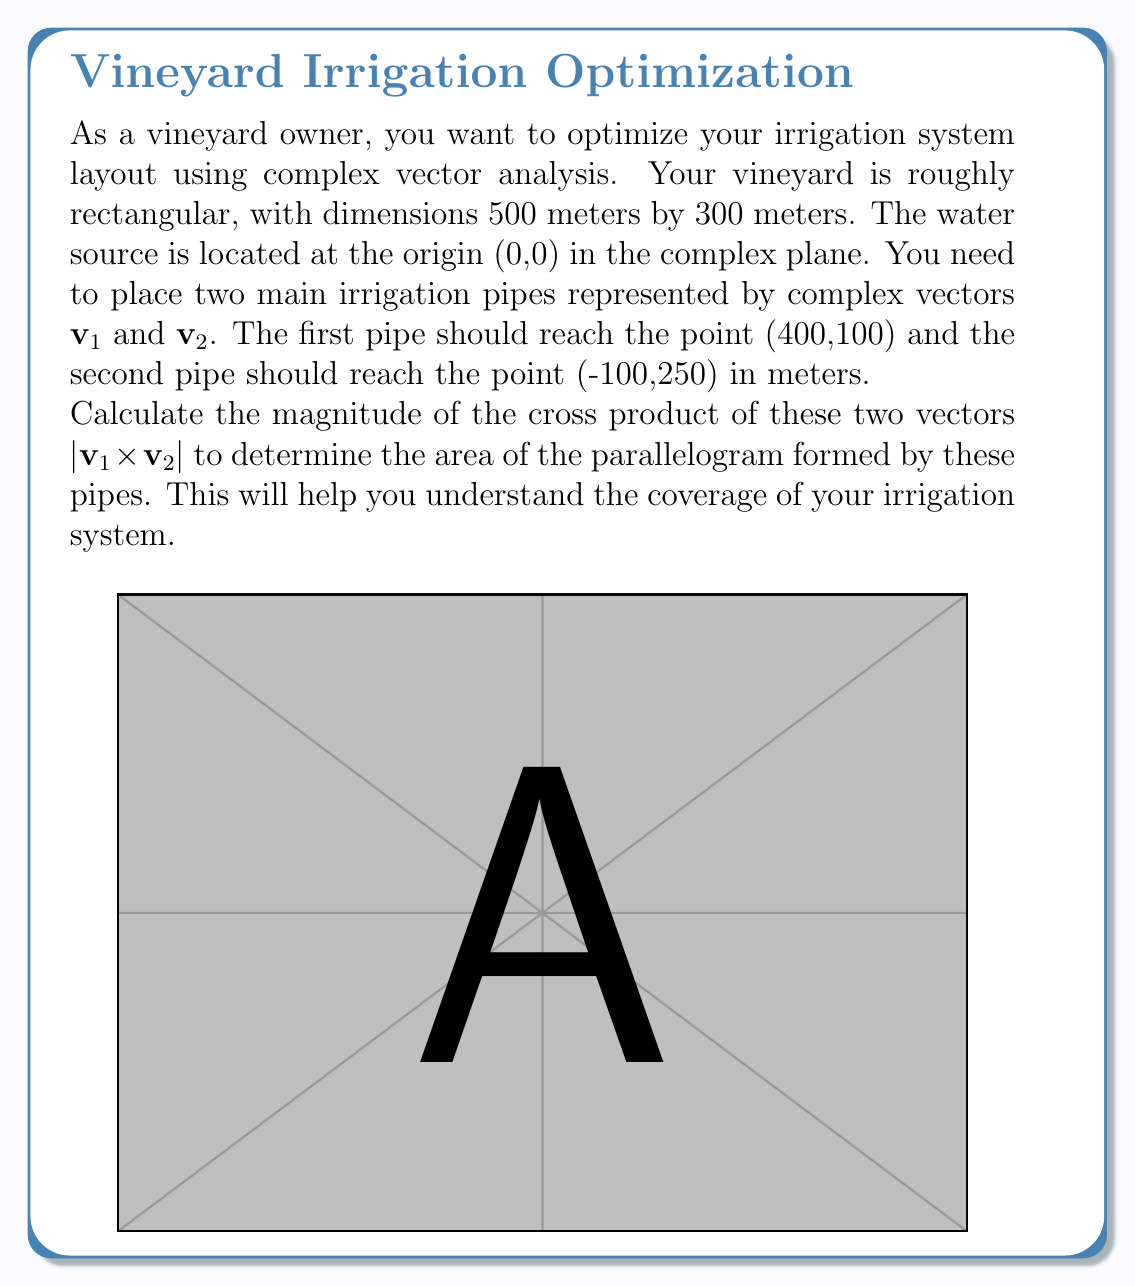Solve this math problem. Let's approach this step-by-step:

1) First, we need to represent the vectors in complex form:
   $\mathbf{v}_1 = 400 + 100i$
   $\mathbf{v}_2 = -100 + 250i$

2) To find the cross product of two complex vectors $\mathbf{a} = a_1 + a_2i$ and $\mathbf{b} = b_1 + b_2i$, we use the formula:
   $$|\mathbf{a} \times \mathbf{b}| = |a_1b_2 - a_2b_1|$$

3) In our case:
   $a_1 = 400$, $a_2 = 100$
   $b_1 = -100$, $b_2 = 250$

4) Let's substitute these values into the formula:
   $$|\mathbf{v}_1 \times \mathbf{v}_2| = |400(250) - 100(-100)|$$

5) Simplify:
   $$|\mathbf{v}_1 \times \mathbf{v}_2| = |100,000 + 10,000| = |110,000|$$

6) The absolute value of a positive number is the number itself, so:
   $$|\mathbf{v}_1 \times \mathbf{v}_2| = 110,000$$

7) This result is in square meters, as we multiplied distances in meters.

The magnitude of the cross product, 110,000 square meters, represents the area of the parallelogram formed by these two irrigation pipes. This gives you an idea of the coverage of your irrigation system in the vineyard.
Answer: The magnitude of the cross product $|\mathbf{v}_1 \times \mathbf{v}_2|$ is 110,000 square meters. 